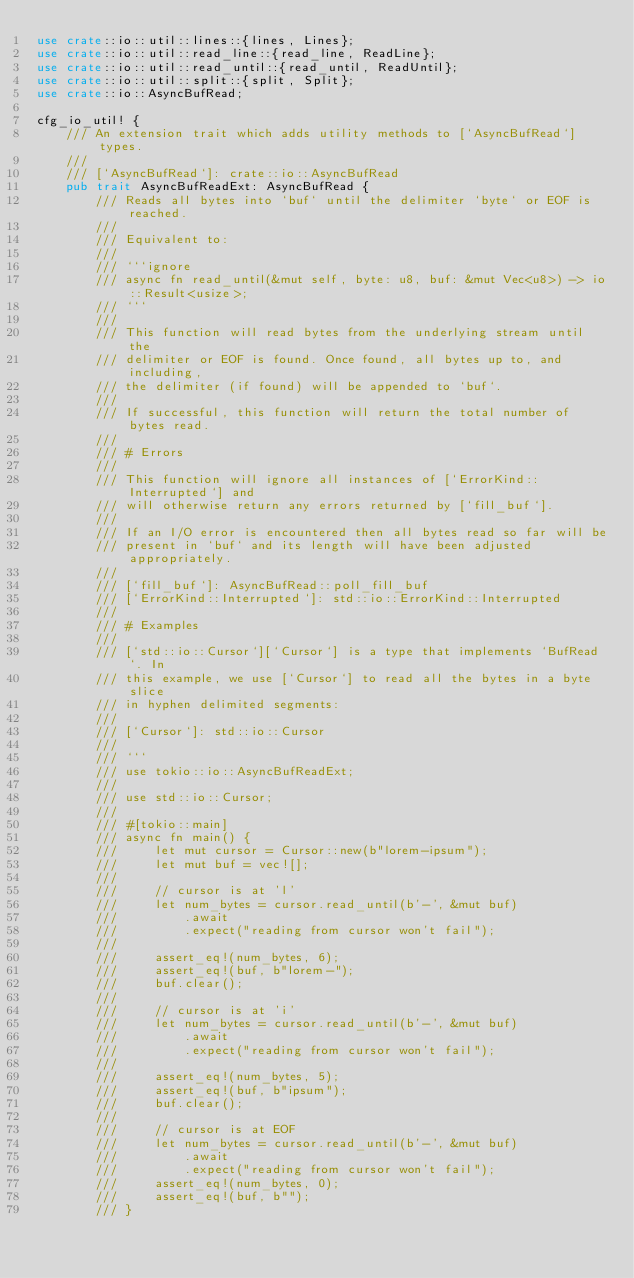Convert code to text. <code><loc_0><loc_0><loc_500><loc_500><_Rust_>use crate::io::util::lines::{lines, Lines};
use crate::io::util::read_line::{read_line, ReadLine};
use crate::io::util::read_until::{read_until, ReadUntil};
use crate::io::util::split::{split, Split};
use crate::io::AsyncBufRead;

cfg_io_util! {
    /// An extension trait which adds utility methods to [`AsyncBufRead`] types.
    ///
    /// [`AsyncBufRead`]: crate::io::AsyncBufRead
    pub trait AsyncBufReadExt: AsyncBufRead {
        /// Reads all bytes into `buf` until the delimiter `byte` or EOF is reached.
        ///
        /// Equivalent to:
        ///
        /// ```ignore
        /// async fn read_until(&mut self, byte: u8, buf: &mut Vec<u8>) -> io::Result<usize>;
        /// ```
        ///
        /// This function will read bytes from the underlying stream until the
        /// delimiter or EOF is found. Once found, all bytes up to, and including,
        /// the delimiter (if found) will be appended to `buf`.
        ///
        /// If successful, this function will return the total number of bytes read.
        ///
        /// # Errors
        ///
        /// This function will ignore all instances of [`ErrorKind::Interrupted`] and
        /// will otherwise return any errors returned by [`fill_buf`].
        ///
        /// If an I/O error is encountered then all bytes read so far will be
        /// present in `buf` and its length will have been adjusted appropriately.
        ///
        /// [`fill_buf`]: AsyncBufRead::poll_fill_buf
        /// [`ErrorKind::Interrupted`]: std::io::ErrorKind::Interrupted
        ///
        /// # Examples
        ///
        /// [`std::io::Cursor`][`Cursor`] is a type that implements `BufRead`. In
        /// this example, we use [`Cursor`] to read all the bytes in a byte slice
        /// in hyphen delimited segments:
        ///
        /// [`Cursor`]: std::io::Cursor
        ///
        /// ```
        /// use tokio::io::AsyncBufReadExt;
        ///
        /// use std::io::Cursor;
        ///
        /// #[tokio::main]
        /// async fn main() {
        ///     let mut cursor = Cursor::new(b"lorem-ipsum");
        ///     let mut buf = vec![];
        ///
        ///     // cursor is at 'l'
        ///     let num_bytes = cursor.read_until(b'-', &mut buf)
        ///         .await
        ///         .expect("reading from cursor won't fail");
        ///
        ///     assert_eq!(num_bytes, 6);
        ///     assert_eq!(buf, b"lorem-");
        ///     buf.clear();
        ///
        ///     // cursor is at 'i'
        ///     let num_bytes = cursor.read_until(b'-', &mut buf)
        ///         .await
        ///         .expect("reading from cursor won't fail");
        ///
        ///     assert_eq!(num_bytes, 5);
        ///     assert_eq!(buf, b"ipsum");
        ///     buf.clear();
        ///
        ///     // cursor is at EOF
        ///     let num_bytes = cursor.read_until(b'-', &mut buf)
        ///         .await
        ///         .expect("reading from cursor won't fail");
        ///     assert_eq!(num_bytes, 0);
        ///     assert_eq!(buf, b"");
        /// }</code> 